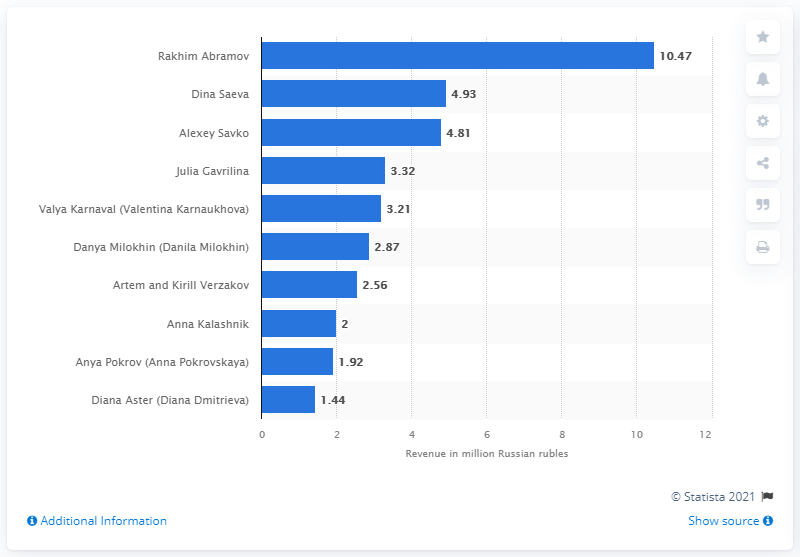Outline some significant characteristics in this image. Dina Saeva was the second most successful Russian-speaking blogger on TikTok. Rakhim Abramov was the most successful Russian-speaking blogger on TikTok. 